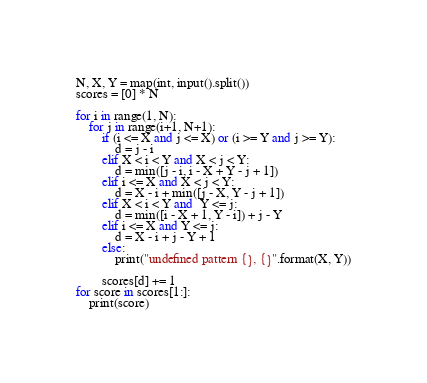Convert code to text. <code><loc_0><loc_0><loc_500><loc_500><_Python_>N, X, Y = map(int, input().split())
scores = [0] * N

for i in range(1, N):
    for j in range(i+1, N+1):
        if (i <= X and j <= X) or (i >= Y and j >= Y):
            d = j - i
        elif X < i < Y and X < j < Y:
            d = min([j - i, i - X + Y - j + 1])
        elif i <= X and X < j < Y:
            d = X - i + min([j - X, Y - j + 1])
        elif X < i < Y and  Y <= j:
            d = min([i - X + 1, Y - i]) + j - Y
        elif i <= X and Y <= j:
            d = X - i + j - Y + 1
        else:
            print("undefined pattern {}, {}".format(X, Y))

        scores[d] += 1
for score in scores[1:]:
    print(score)</code> 